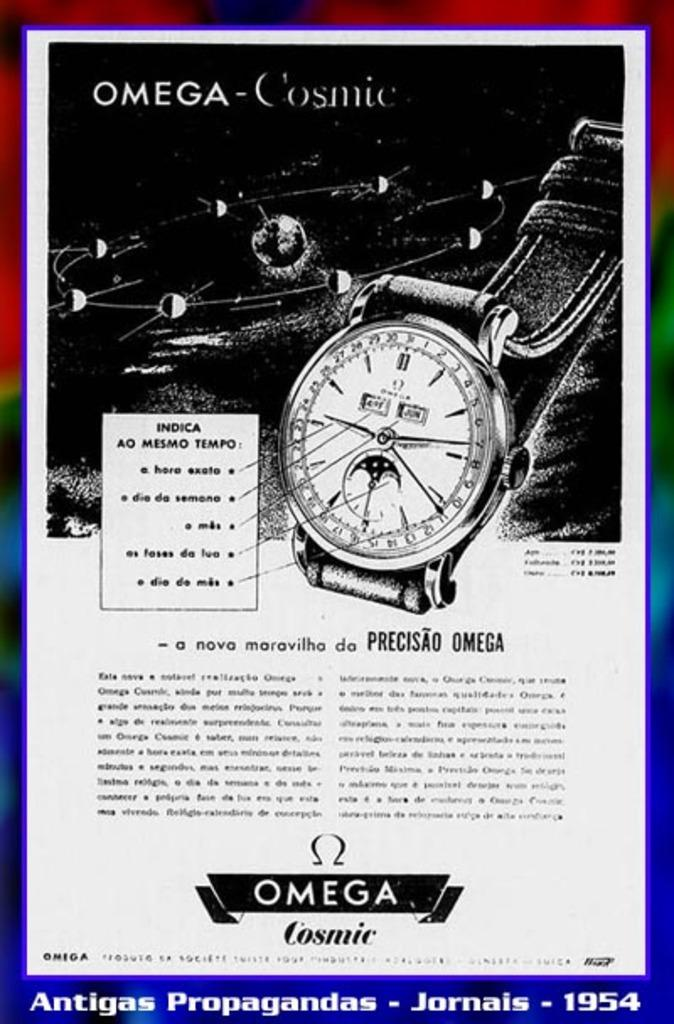<image>
Create a compact narrative representing the image presented. An advertisement about a watch that is the Omega Cosmic. 